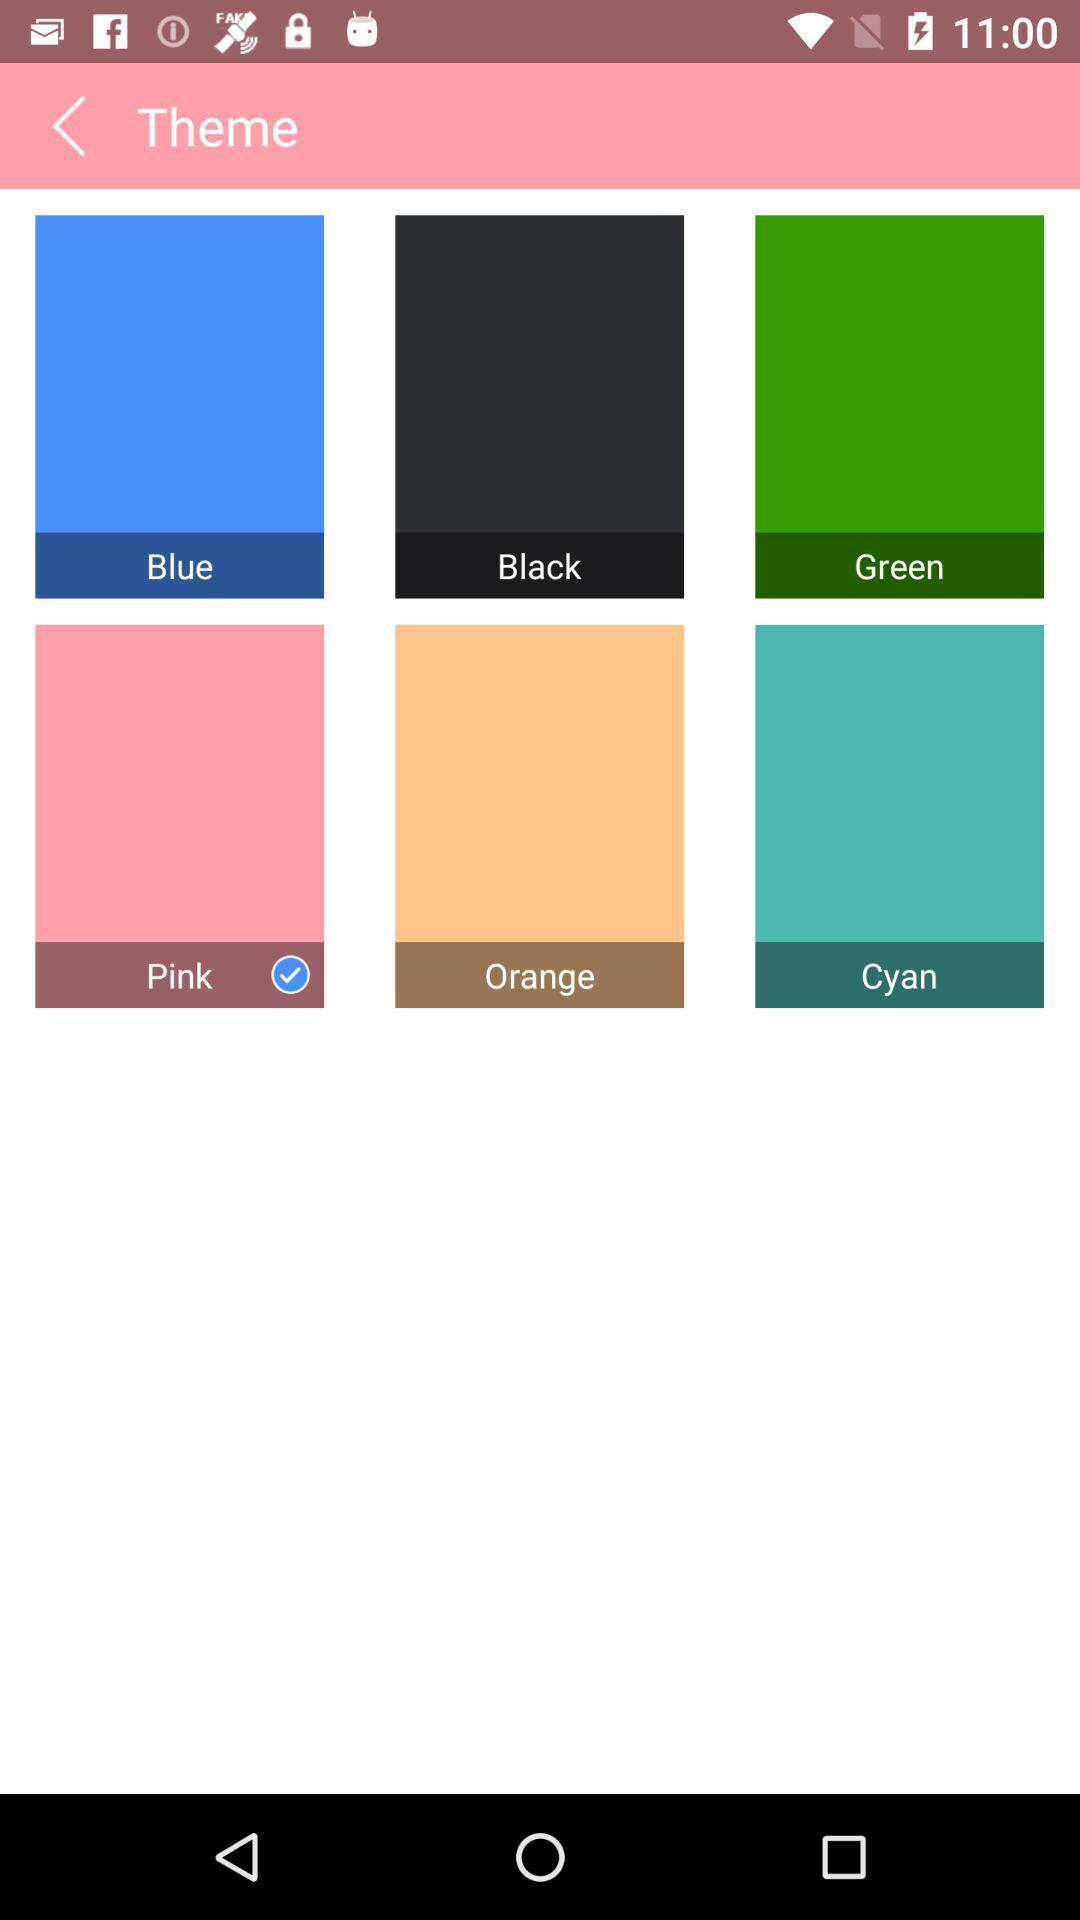Which theme color is selected? The selected theme color is "Pink". 